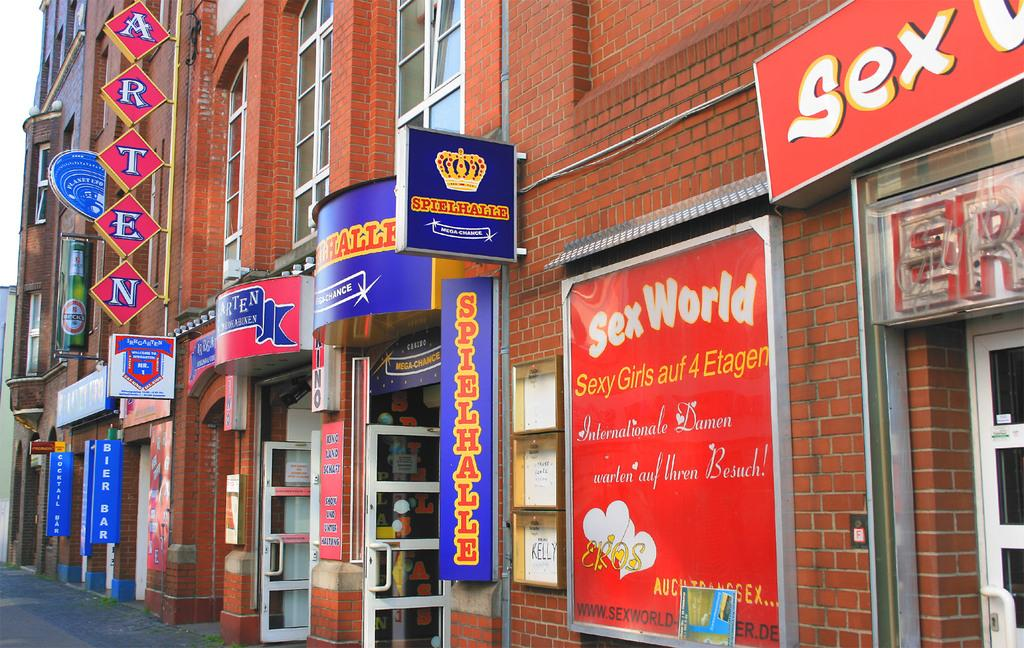What is the main subject of the image? The main subject of the image is a building. Can you describe the view of the building in the image? The image contains a front view of the building. What type of juice is being sold in the store located in the building? There is no store or juice mentioned in the image; it only features a front view of a building. 